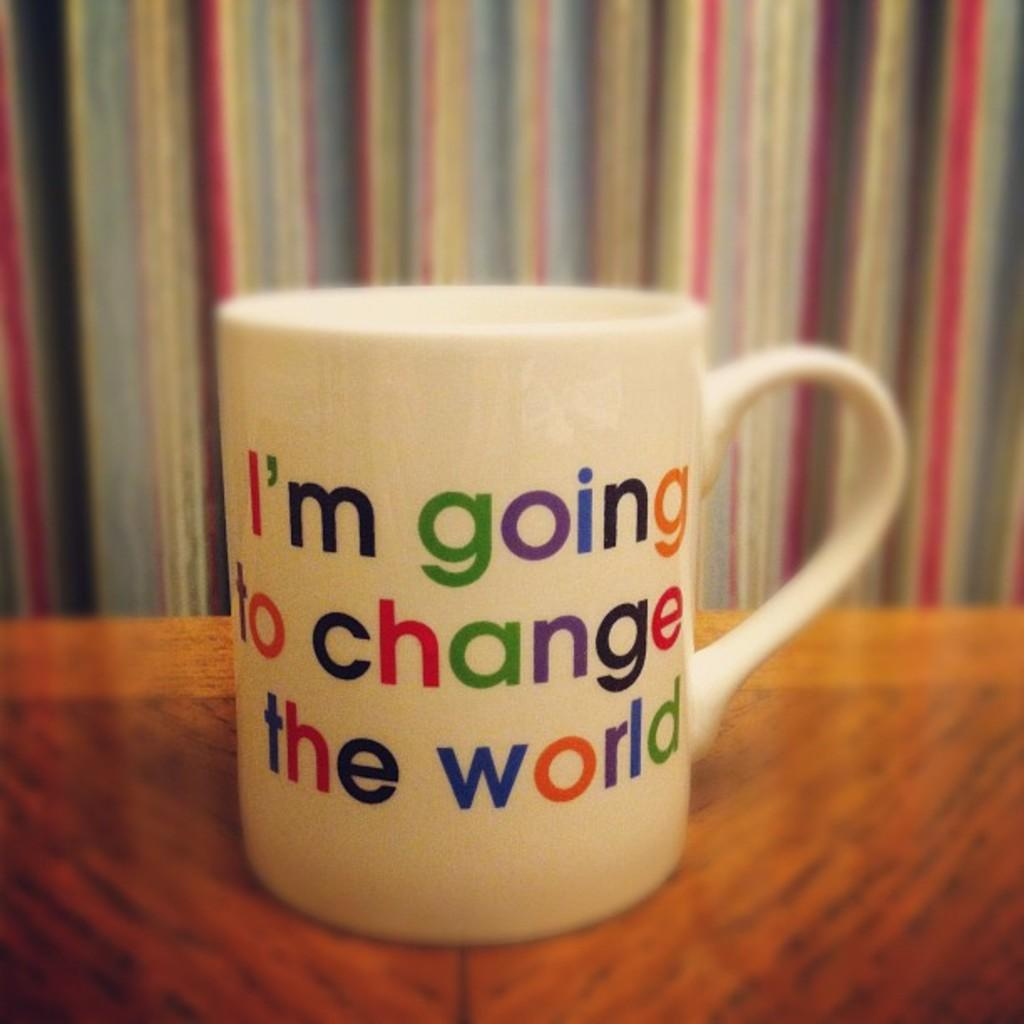<image>
Summarize the visual content of the image. A white mug with colorful letters that read, "I'm going to change the world." 